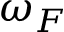Convert formula to latex. <formula><loc_0><loc_0><loc_500><loc_500>\omega _ { F }</formula> 